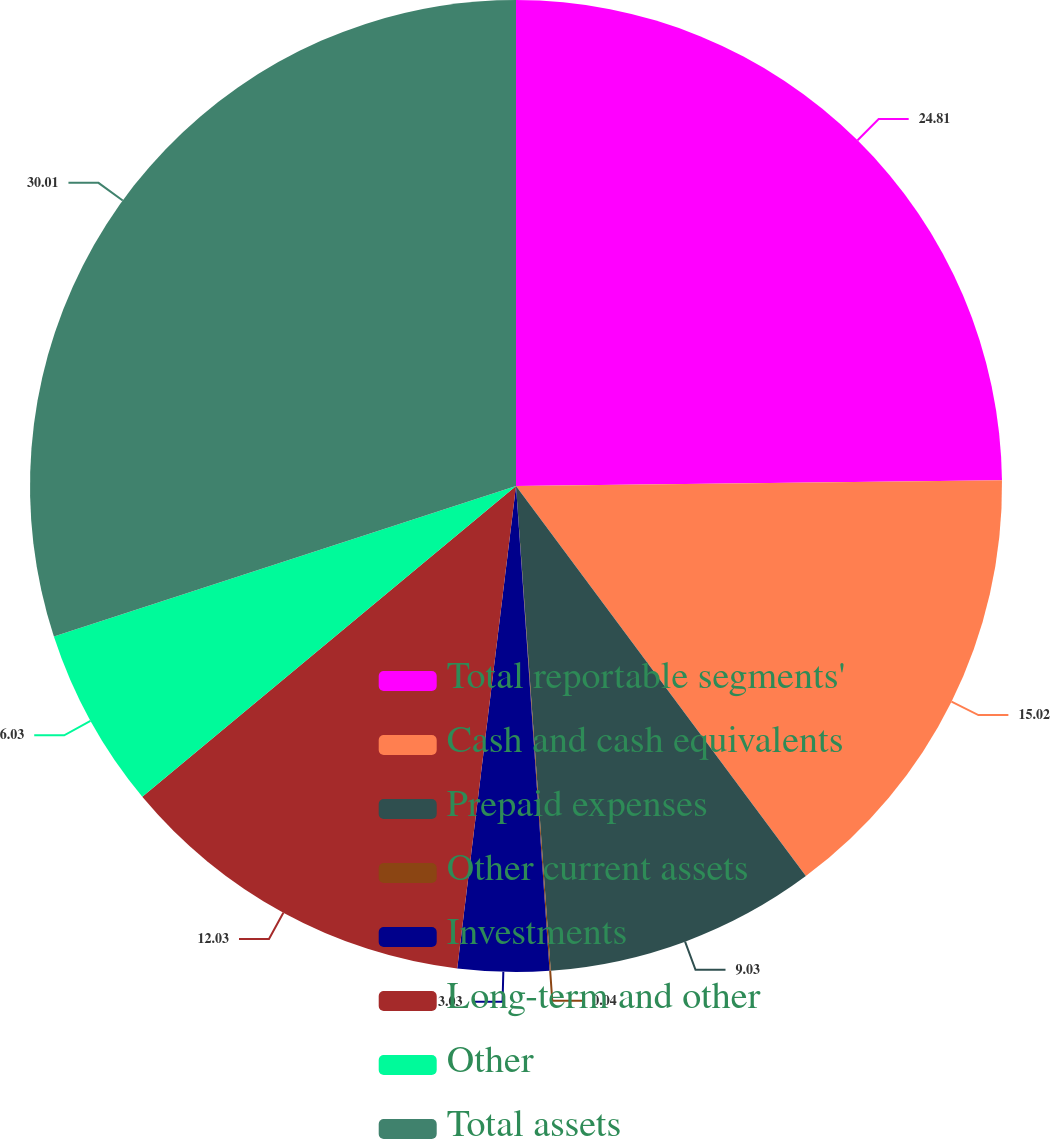<chart> <loc_0><loc_0><loc_500><loc_500><pie_chart><fcel>Total reportable segments'<fcel>Cash and cash equivalents<fcel>Prepaid expenses<fcel>Other current assets<fcel>Investments<fcel>Long-term and other<fcel>Other<fcel>Total assets<nl><fcel>24.81%<fcel>15.02%<fcel>9.03%<fcel>0.04%<fcel>3.03%<fcel>12.03%<fcel>6.03%<fcel>30.01%<nl></chart> 